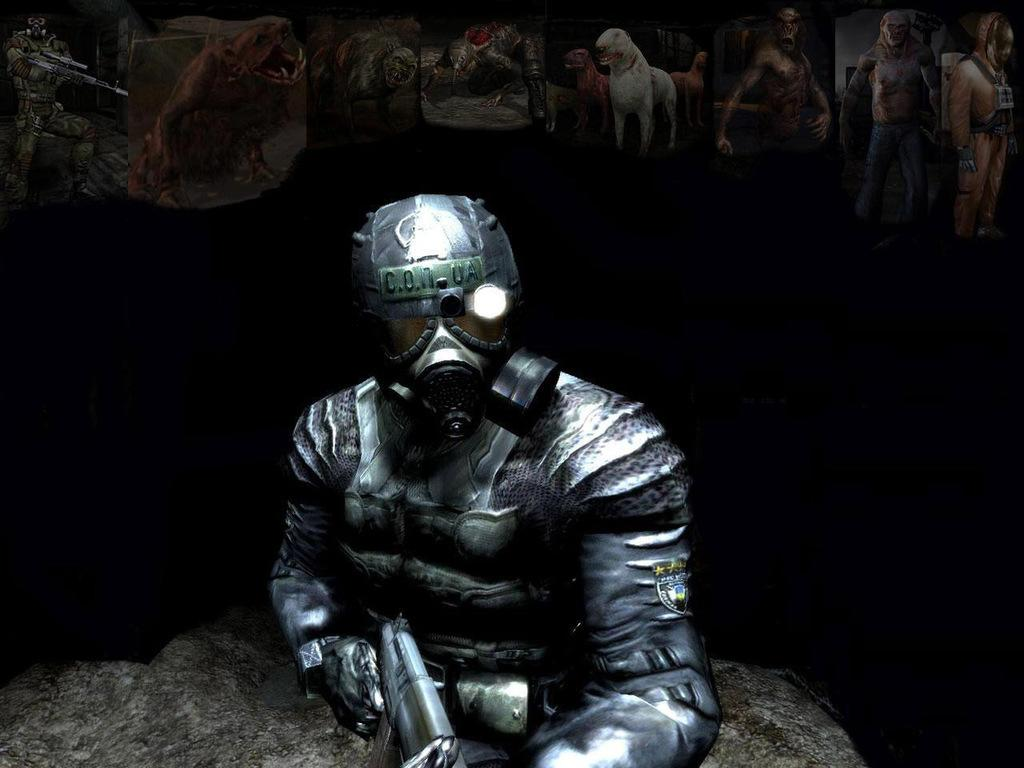What type of image is this? The image is animated. What is happening in the foreground of the image? There is a person wearing a mask in the foreground of the image, and they are holding a gun. What can be seen at the top of the image? There are animals and people at the top of the image. How would you describe the background of the image? The background of the image is dark. What type of story is being told by the donkey in the image? There is no donkey present in the image, so no story can be told by a donkey. Are there any fairies visible in the image? There are no fairies present in the image. 